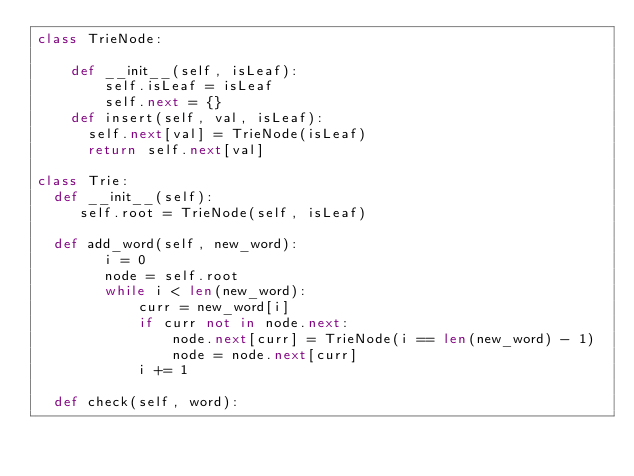<code> <loc_0><loc_0><loc_500><loc_500><_Python_>class TrieNode:

    def __init__(self, isLeaf):
        self.isLeaf = isLeaf
        self.next = {}
    def insert(self, val, isLeaf):
    	self.next[val] = TrieNode(isLeaf)
    	return self.next[val] 

class Trie:
	def __init__(self):
	   self.root = TrieNode(self, isLeaf)

	def add_word(self, new_word):
        i = 0
        node = self.root
        while i < len(new_word):
            curr = new_word[i]
            if curr not in node.next:
                node.next[curr] = TrieNode(i == len(new_word) - 1)
                node = node.next[curr]
            i += 1

	def check(self, word):


</code> 